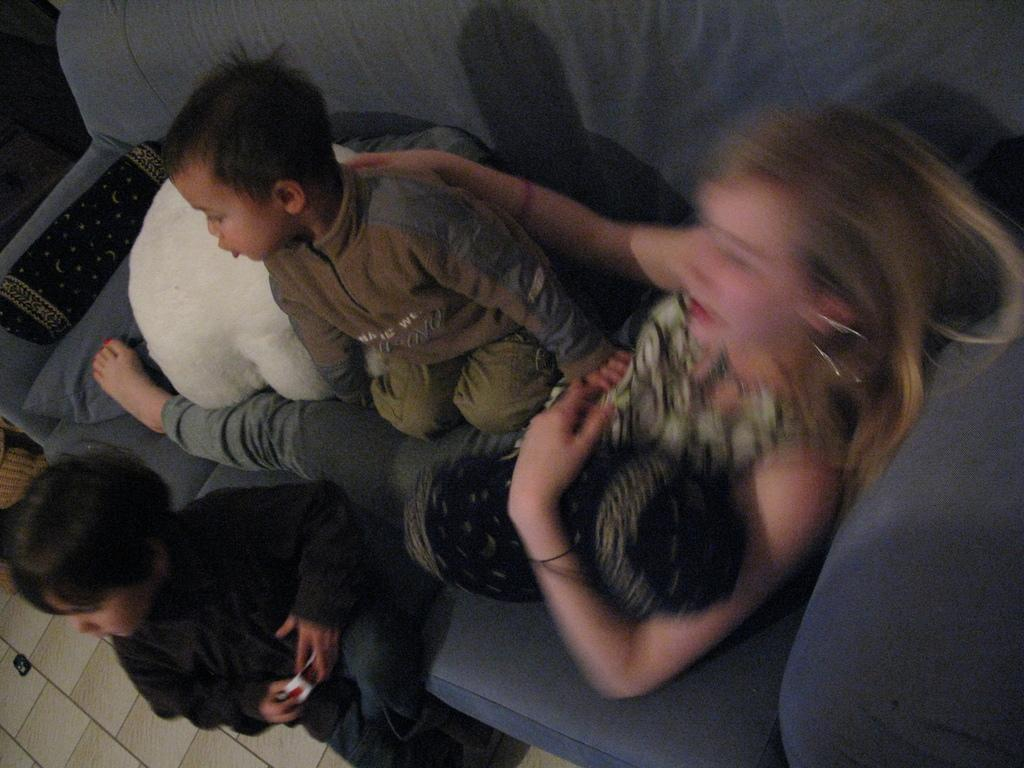What type of furniture is present in the image? There is a sofa in the image. What is placed on the sofa? Cushions are placed on the sofa. Who is present in the image? There is a lady and two kids in the image. What are the lady and kids doing in the image? The lady and kids are sitting on the sofa. What is visible beneath the sofa? There is a floor visible in the image. What type of haircut does the kitten have in the image? There is no kitten present in the image, so it is not possible to answer that question. 